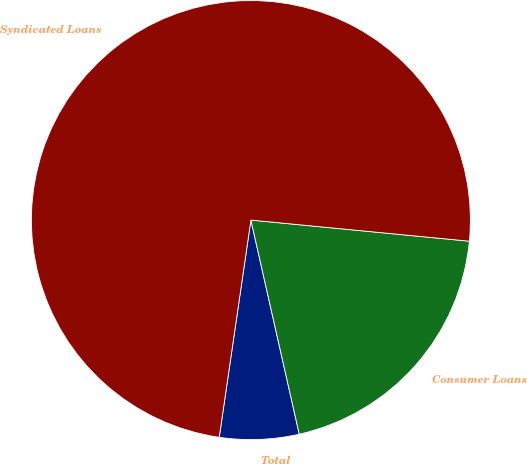Convert chart. <chart><loc_0><loc_0><loc_500><loc_500><pie_chart><fcel>Total<fcel>Consumer Loans<fcel>Syndicated Loans<nl><fcel>5.84%<fcel>19.93%<fcel>74.23%<nl></chart> 